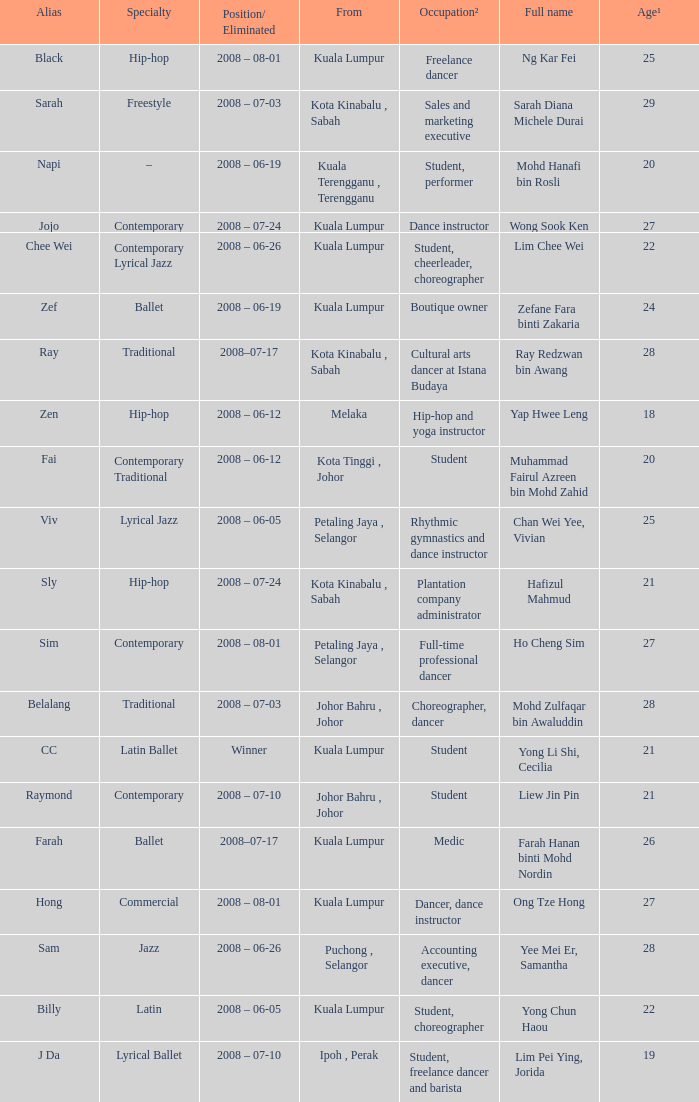What is Position/ Eliminated, when Age¹ is less than 22, and when Full Name is "Muhammad Fairul Azreen Bin Mohd Zahid"? 2008 – 06-12. 